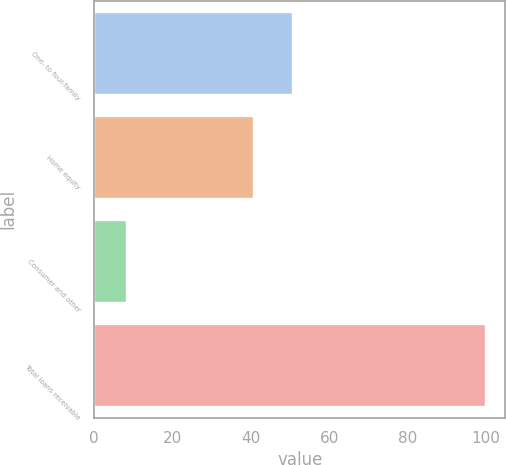<chart> <loc_0><loc_0><loc_500><loc_500><bar_chart><fcel>One- to four-family<fcel>Home equity<fcel>Consumer and other<fcel>Total loans receivable<nl><fcel>50.7<fcel>40.8<fcel>8.5<fcel>100<nl></chart> 